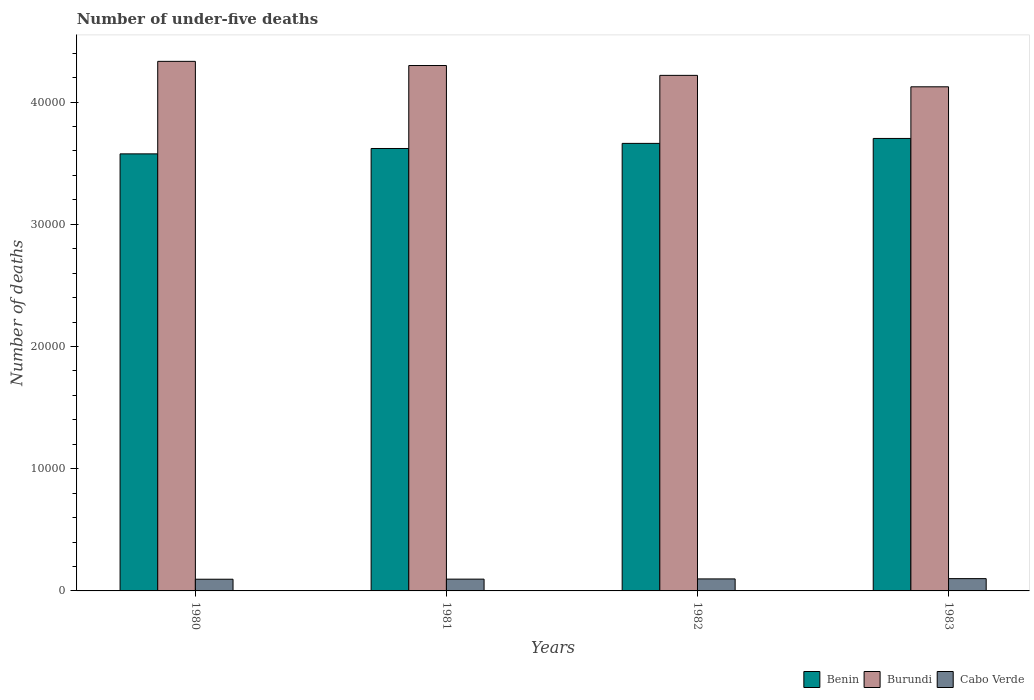How many different coloured bars are there?
Provide a succinct answer. 3. How many groups of bars are there?
Ensure brevity in your answer.  4. Are the number of bars on each tick of the X-axis equal?
Keep it short and to the point. Yes. How many bars are there on the 2nd tick from the right?
Ensure brevity in your answer.  3. What is the number of under-five deaths in Benin in 1983?
Your answer should be very brief. 3.70e+04. Across all years, what is the maximum number of under-five deaths in Benin?
Your answer should be very brief. 3.70e+04. Across all years, what is the minimum number of under-five deaths in Cabo Verde?
Your response must be concise. 957. What is the total number of under-five deaths in Benin in the graph?
Provide a short and direct response. 1.46e+05. What is the difference between the number of under-five deaths in Benin in 1980 and that in 1983?
Offer a very short reply. -1262. What is the difference between the number of under-five deaths in Burundi in 1981 and the number of under-five deaths in Benin in 1980?
Offer a very short reply. 7229. What is the average number of under-five deaths in Cabo Verde per year?
Give a very brief answer. 977.5. In the year 1981, what is the difference between the number of under-five deaths in Burundi and number of under-five deaths in Benin?
Your answer should be very brief. 6789. What is the ratio of the number of under-five deaths in Burundi in 1980 to that in 1981?
Give a very brief answer. 1.01. Is the difference between the number of under-five deaths in Burundi in 1982 and 1983 greater than the difference between the number of under-five deaths in Benin in 1982 and 1983?
Offer a very short reply. Yes. What is the difference between the highest and the second highest number of under-five deaths in Burundi?
Make the answer very short. 341. What is the difference between the highest and the lowest number of under-five deaths in Benin?
Provide a succinct answer. 1262. Is the sum of the number of under-five deaths in Cabo Verde in 1980 and 1981 greater than the maximum number of under-five deaths in Burundi across all years?
Keep it short and to the point. No. What does the 1st bar from the left in 1980 represents?
Ensure brevity in your answer.  Benin. What does the 3rd bar from the right in 1982 represents?
Ensure brevity in your answer.  Benin. Is it the case that in every year, the sum of the number of under-five deaths in Benin and number of under-five deaths in Cabo Verde is greater than the number of under-five deaths in Burundi?
Ensure brevity in your answer.  No. Are all the bars in the graph horizontal?
Provide a succinct answer. No. What is the difference between two consecutive major ticks on the Y-axis?
Ensure brevity in your answer.  10000. Are the values on the major ticks of Y-axis written in scientific E-notation?
Offer a terse response. No. Does the graph contain any zero values?
Your response must be concise. No. Where does the legend appear in the graph?
Provide a succinct answer. Bottom right. How are the legend labels stacked?
Make the answer very short. Horizontal. What is the title of the graph?
Provide a succinct answer. Number of under-five deaths. Does "South Sudan" appear as one of the legend labels in the graph?
Provide a succinct answer. No. What is the label or title of the Y-axis?
Keep it short and to the point. Number of deaths. What is the Number of deaths in Benin in 1980?
Your response must be concise. 3.58e+04. What is the Number of deaths of Burundi in 1980?
Your answer should be compact. 4.33e+04. What is the Number of deaths of Cabo Verde in 1980?
Your answer should be very brief. 957. What is the Number of deaths in Benin in 1981?
Your response must be concise. 3.62e+04. What is the Number of deaths in Burundi in 1981?
Ensure brevity in your answer.  4.30e+04. What is the Number of deaths of Cabo Verde in 1981?
Offer a very short reply. 965. What is the Number of deaths of Benin in 1982?
Give a very brief answer. 3.66e+04. What is the Number of deaths in Burundi in 1982?
Keep it short and to the point. 4.22e+04. What is the Number of deaths in Cabo Verde in 1982?
Provide a short and direct response. 983. What is the Number of deaths of Benin in 1983?
Offer a very short reply. 3.70e+04. What is the Number of deaths in Burundi in 1983?
Make the answer very short. 4.13e+04. What is the Number of deaths in Cabo Verde in 1983?
Offer a terse response. 1005. Across all years, what is the maximum Number of deaths of Benin?
Provide a short and direct response. 3.70e+04. Across all years, what is the maximum Number of deaths of Burundi?
Provide a succinct answer. 4.33e+04. Across all years, what is the maximum Number of deaths in Cabo Verde?
Offer a terse response. 1005. Across all years, what is the minimum Number of deaths of Benin?
Ensure brevity in your answer.  3.58e+04. Across all years, what is the minimum Number of deaths in Burundi?
Your answer should be compact. 4.13e+04. Across all years, what is the minimum Number of deaths in Cabo Verde?
Your answer should be compact. 957. What is the total Number of deaths in Benin in the graph?
Offer a terse response. 1.46e+05. What is the total Number of deaths in Burundi in the graph?
Make the answer very short. 1.70e+05. What is the total Number of deaths in Cabo Verde in the graph?
Keep it short and to the point. 3910. What is the difference between the Number of deaths of Benin in 1980 and that in 1981?
Your response must be concise. -440. What is the difference between the Number of deaths of Burundi in 1980 and that in 1981?
Make the answer very short. 341. What is the difference between the Number of deaths in Cabo Verde in 1980 and that in 1981?
Keep it short and to the point. -8. What is the difference between the Number of deaths in Benin in 1980 and that in 1982?
Your answer should be very brief. -857. What is the difference between the Number of deaths of Burundi in 1980 and that in 1982?
Provide a short and direct response. 1147. What is the difference between the Number of deaths of Cabo Verde in 1980 and that in 1982?
Ensure brevity in your answer.  -26. What is the difference between the Number of deaths of Benin in 1980 and that in 1983?
Offer a very short reply. -1262. What is the difference between the Number of deaths in Burundi in 1980 and that in 1983?
Your response must be concise. 2083. What is the difference between the Number of deaths of Cabo Verde in 1980 and that in 1983?
Offer a very short reply. -48. What is the difference between the Number of deaths of Benin in 1981 and that in 1982?
Keep it short and to the point. -417. What is the difference between the Number of deaths in Burundi in 1981 and that in 1982?
Your answer should be compact. 806. What is the difference between the Number of deaths in Cabo Verde in 1981 and that in 1982?
Provide a short and direct response. -18. What is the difference between the Number of deaths of Benin in 1981 and that in 1983?
Offer a terse response. -822. What is the difference between the Number of deaths in Burundi in 1981 and that in 1983?
Your answer should be compact. 1742. What is the difference between the Number of deaths of Benin in 1982 and that in 1983?
Your response must be concise. -405. What is the difference between the Number of deaths of Burundi in 1982 and that in 1983?
Keep it short and to the point. 936. What is the difference between the Number of deaths of Cabo Verde in 1982 and that in 1983?
Offer a very short reply. -22. What is the difference between the Number of deaths in Benin in 1980 and the Number of deaths in Burundi in 1981?
Your answer should be very brief. -7229. What is the difference between the Number of deaths of Benin in 1980 and the Number of deaths of Cabo Verde in 1981?
Make the answer very short. 3.48e+04. What is the difference between the Number of deaths of Burundi in 1980 and the Number of deaths of Cabo Verde in 1981?
Keep it short and to the point. 4.24e+04. What is the difference between the Number of deaths in Benin in 1980 and the Number of deaths in Burundi in 1982?
Your answer should be compact. -6423. What is the difference between the Number of deaths of Benin in 1980 and the Number of deaths of Cabo Verde in 1982?
Your response must be concise. 3.48e+04. What is the difference between the Number of deaths in Burundi in 1980 and the Number of deaths in Cabo Verde in 1982?
Offer a very short reply. 4.24e+04. What is the difference between the Number of deaths in Benin in 1980 and the Number of deaths in Burundi in 1983?
Give a very brief answer. -5487. What is the difference between the Number of deaths in Benin in 1980 and the Number of deaths in Cabo Verde in 1983?
Your answer should be compact. 3.48e+04. What is the difference between the Number of deaths in Burundi in 1980 and the Number of deaths in Cabo Verde in 1983?
Offer a terse response. 4.23e+04. What is the difference between the Number of deaths of Benin in 1981 and the Number of deaths of Burundi in 1982?
Provide a succinct answer. -5983. What is the difference between the Number of deaths of Benin in 1981 and the Number of deaths of Cabo Verde in 1982?
Make the answer very short. 3.52e+04. What is the difference between the Number of deaths in Burundi in 1981 and the Number of deaths in Cabo Verde in 1982?
Provide a short and direct response. 4.20e+04. What is the difference between the Number of deaths in Benin in 1981 and the Number of deaths in Burundi in 1983?
Your answer should be compact. -5047. What is the difference between the Number of deaths in Benin in 1981 and the Number of deaths in Cabo Verde in 1983?
Keep it short and to the point. 3.52e+04. What is the difference between the Number of deaths of Burundi in 1981 and the Number of deaths of Cabo Verde in 1983?
Your answer should be compact. 4.20e+04. What is the difference between the Number of deaths of Benin in 1982 and the Number of deaths of Burundi in 1983?
Ensure brevity in your answer.  -4630. What is the difference between the Number of deaths in Benin in 1982 and the Number of deaths in Cabo Verde in 1983?
Keep it short and to the point. 3.56e+04. What is the difference between the Number of deaths in Burundi in 1982 and the Number of deaths in Cabo Verde in 1983?
Offer a very short reply. 4.12e+04. What is the average Number of deaths of Benin per year?
Provide a succinct answer. 3.64e+04. What is the average Number of deaths of Burundi per year?
Offer a terse response. 4.24e+04. What is the average Number of deaths in Cabo Verde per year?
Provide a short and direct response. 977.5. In the year 1980, what is the difference between the Number of deaths in Benin and Number of deaths in Burundi?
Keep it short and to the point. -7570. In the year 1980, what is the difference between the Number of deaths in Benin and Number of deaths in Cabo Verde?
Make the answer very short. 3.48e+04. In the year 1980, what is the difference between the Number of deaths in Burundi and Number of deaths in Cabo Verde?
Make the answer very short. 4.24e+04. In the year 1981, what is the difference between the Number of deaths in Benin and Number of deaths in Burundi?
Provide a succinct answer. -6789. In the year 1981, what is the difference between the Number of deaths in Benin and Number of deaths in Cabo Verde?
Make the answer very short. 3.52e+04. In the year 1981, what is the difference between the Number of deaths of Burundi and Number of deaths of Cabo Verde?
Your answer should be compact. 4.20e+04. In the year 1982, what is the difference between the Number of deaths in Benin and Number of deaths in Burundi?
Make the answer very short. -5566. In the year 1982, what is the difference between the Number of deaths in Benin and Number of deaths in Cabo Verde?
Give a very brief answer. 3.56e+04. In the year 1982, what is the difference between the Number of deaths in Burundi and Number of deaths in Cabo Verde?
Offer a very short reply. 4.12e+04. In the year 1983, what is the difference between the Number of deaths in Benin and Number of deaths in Burundi?
Make the answer very short. -4225. In the year 1983, what is the difference between the Number of deaths in Benin and Number of deaths in Cabo Verde?
Keep it short and to the point. 3.60e+04. In the year 1983, what is the difference between the Number of deaths in Burundi and Number of deaths in Cabo Verde?
Your response must be concise. 4.02e+04. What is the ratio of the Number of deaths of Benin in 1980 to that in 1981?
Keep it short and to the point. 0.99. What is the ratio of the Number of deaths of Burundi in 1980 to that in 1981?
Offer a very short reply. 1.01. What is the ratio of the Number of deaths in Cabo Verde in 1980 to that in 1981?
Make the answer very short. 0.99. What is the ratio of the Number of deaths of Benin in 1980 to that in 1982?
Ensure brevity in your answer.  0.98. What is the ratio of the Number of deaths in Burundi in 1980 to that in 1982?
Your answer should be compact. 1.03. What is the ratio of the Number of deaths of Cabo Verde in 1980 to that in 1982?
Your response must be concise. 0.97. What is the ratio of the Number of deaths of Benin in 1980 to that in 1983?
Keep it short and to the point. 0.97. What is the ratio of the Number of deaths of Burundi in 1980 to that in 1983?
Provide a succinct answer. 1.05. What is the ratio of the Number of deaths of Cabo Verde in 1980 to that in 1983?
Your answer should be very brief. 0.95. What is the ratio of the Number of deaths in Benin in 1981 to that in 1982?
Ensure brevity in your answer.  0.99. What is the ratio of the Number of deaths in Burundi in 1981 to that in 1982?
Your answer should be compact. 1.02. What is the ratio of the Number of deaths in Cabo Verde in 1981 to that in 1982?
Give a very brief answer. 0.98. What is the ratio of the Number of deaths in Benin in 1981 to that in 1983?
Keep it short and to the point. 0.98. What is the ratio of the Number of deaths in Burundi in 1981 to that in 1983?
Your answer should be compact. 1.04. What is the ratio of the Number of deaths of Cabo Verde in 1981 to that in 1983?
Offer a terse response. 0.96. What is the ratio of the Number of deaths in Burundi in 1982 to that in 1983?
Offer a terse response. 1.02. What is the ratio of the Number of deaths in Cabo Verde in 1982 to that in 1983?
Offer a very short reply. 0.98. What is the difference between the highest and the second highest Number of deaths in Benin?
Make the answer very short. 405. What is the difference between the highest and the second highest Number of deaths in Burundi?
Your response must be concise. 341. What is the difference between the highest and the second highest Number of deaths in Cabo Verde?
Your answer should be compact. 22. What is the difference between the highest and the lowest Number of deaths in Benin?
Your answer should be very brief. 1262. What is the difference between the highest and the lowest Number of deaths in Burundi?
Your response must be concise. 2083. What is the difference between the highest and the lowest Number of deaths of Cabo Verde?
Ensure brevity in your answer.  48. 